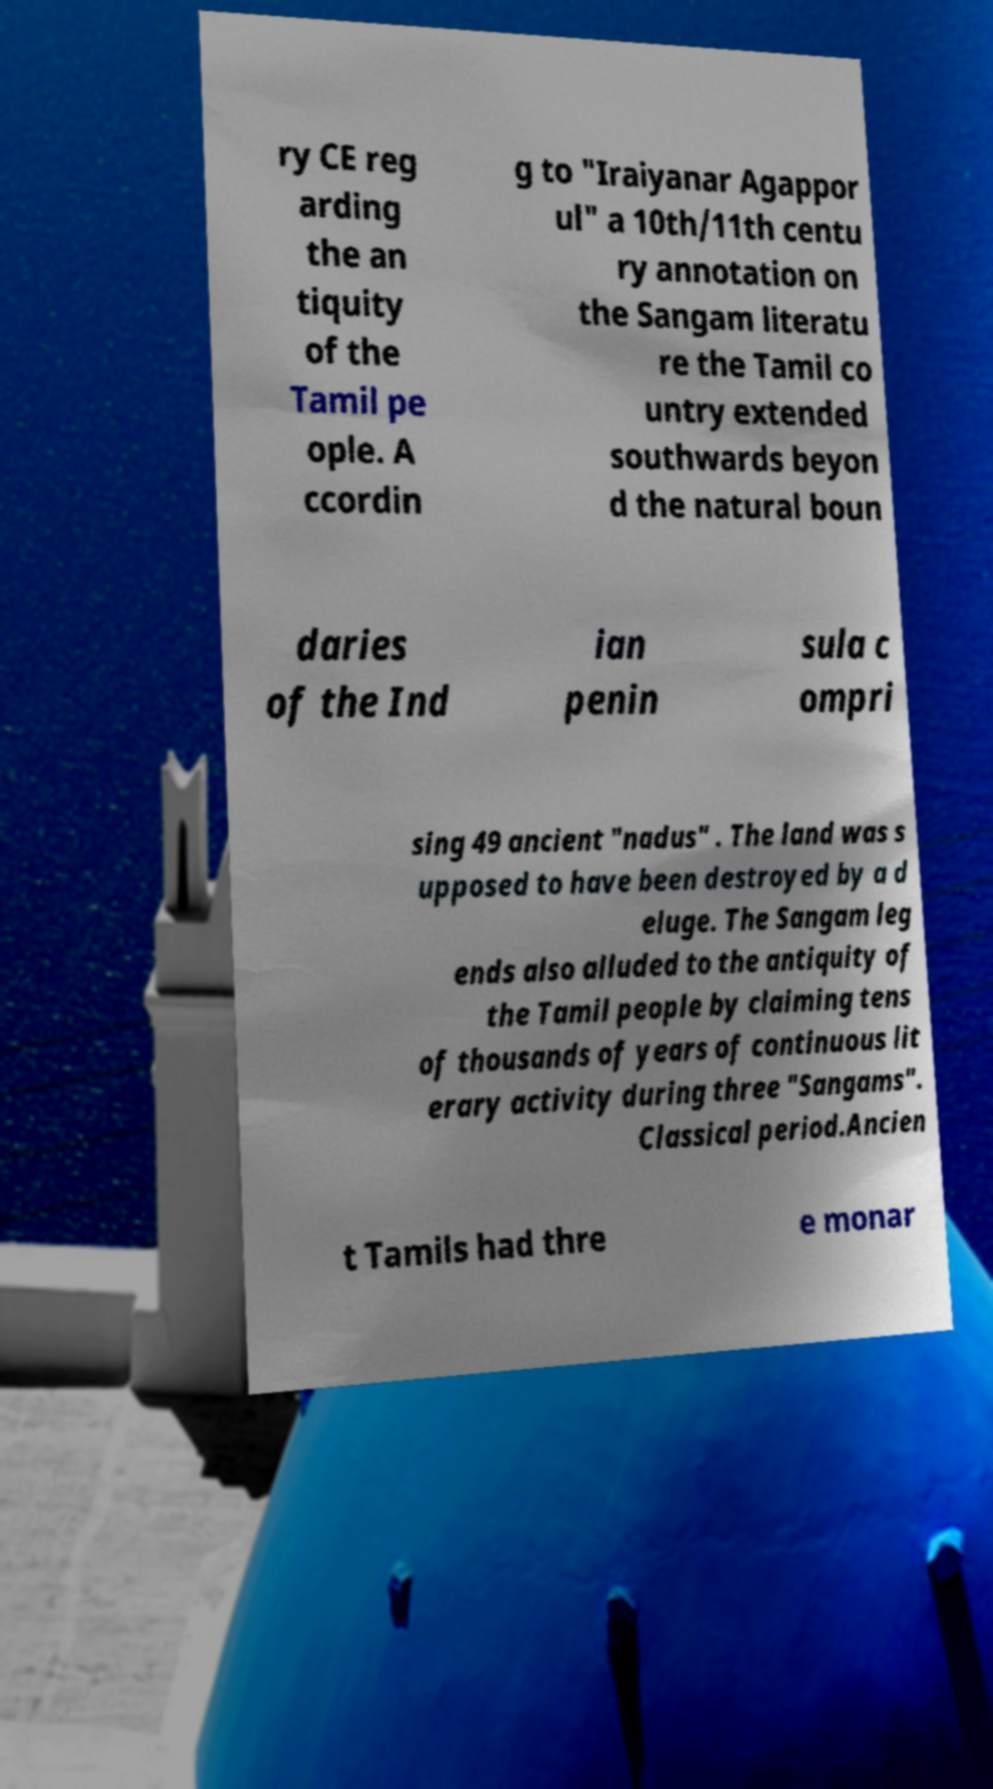Could you assist in decoding the text presented in this image and type it out clearly? ry CE reg arding the an tiquity of the Tamil pe ople. A ccordin g to "Iraiyanar Agappor ul" a 10th/11th centu ry annotation on the Sangam literatu re the Tamil co untry extended southwards beyon d the natural boun daries of the Ind ian penin sula c ompri sing 49 ancient "nadus" . The land was s upposed to have been destroyed by a d eluge. The Sangam leg ends also alluded to the antiquity of the Tamil people by claiming tens of thousands of years of continuous lit erary activity during three "Sangams". Classical period.Ancien t Tamils had thre e monar 